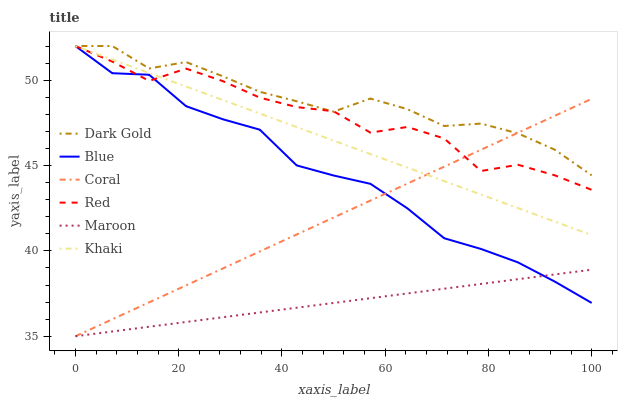Does Khaki have the minimum area under the curve?
Answer yes or no. No. Does Khaki have the maximum area under the curve?
Answer yes or no. No. Is Dark Gold the smoothest?
Answer yes or no. No. Is Dark Gold the roughest?
Answer yes or no. No. Does Khaki have the lowest value?
Answer yes or no. No. Does Coral have the highest value?
Answer yes or no. No. Is Maroon less than Red?
Answer yes or no. Yes. Is Khaki greater than Maroon?
Answer yes or no. Yes. Does Maroon intersect Red?
Answer yes or no. No. 